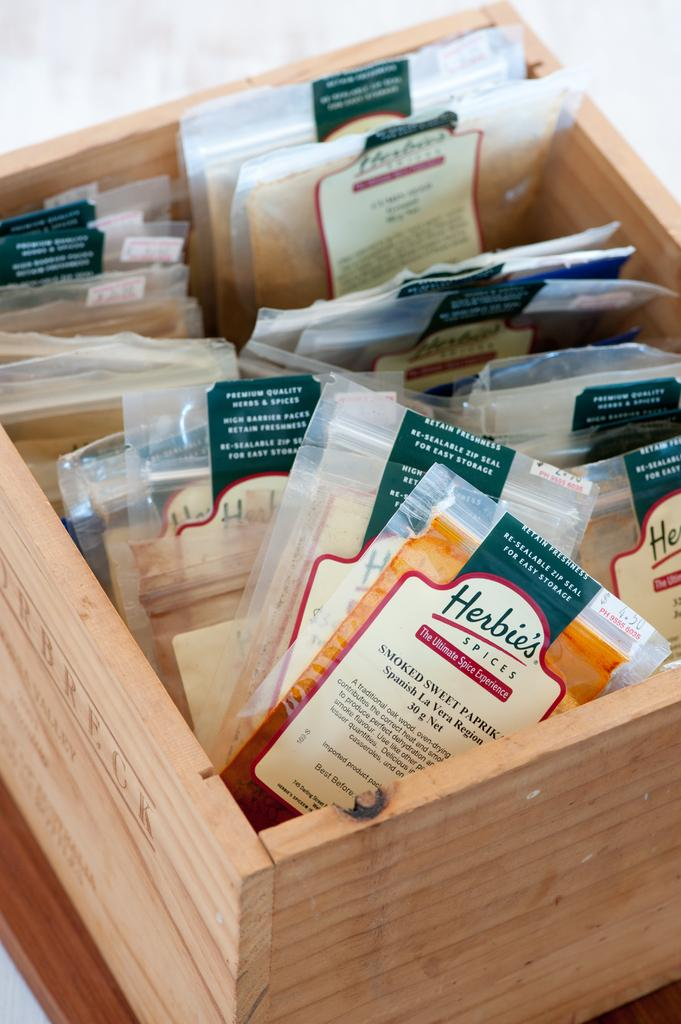<image>
Write a terse but informative summary of the picture. Wooden box with snacks including Herbie's Spices and others. 